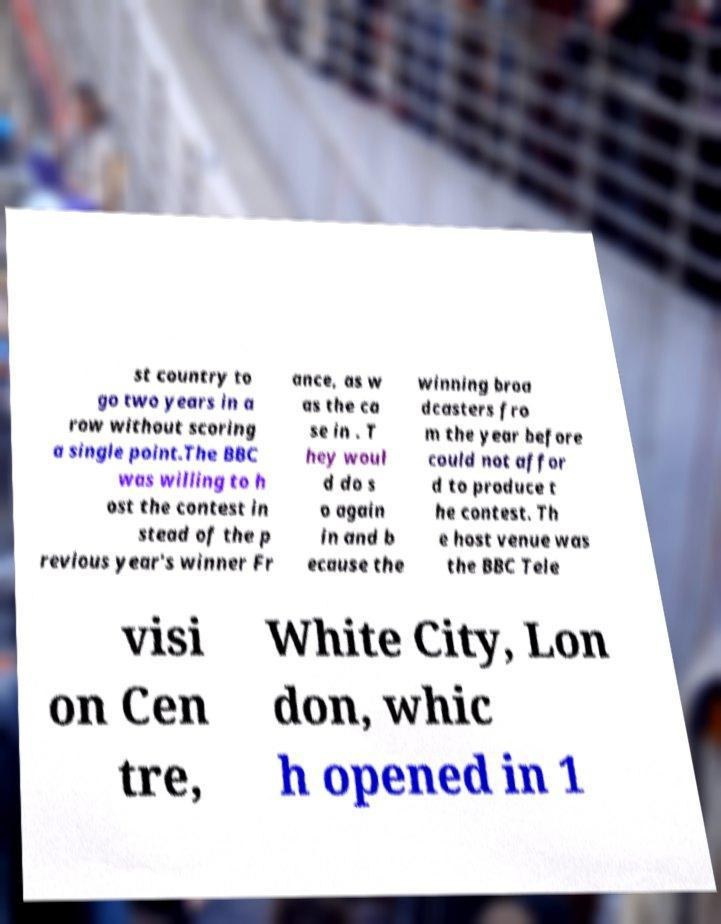Could you extract and type out the text from this image? st country to go two years in a row without scoring a single point.The BBC was willing to h ost the contest in stead of the p revious year's winner Fr ance, as w as the ca se in . T hey woul d do s o again in and b ecause the winning broa dcasters fro m the year before could not affor d to produce t he contest. Th e host venue was the BBC Tele visi on Cen tre, White City, Lon don, whic h opened in 1 